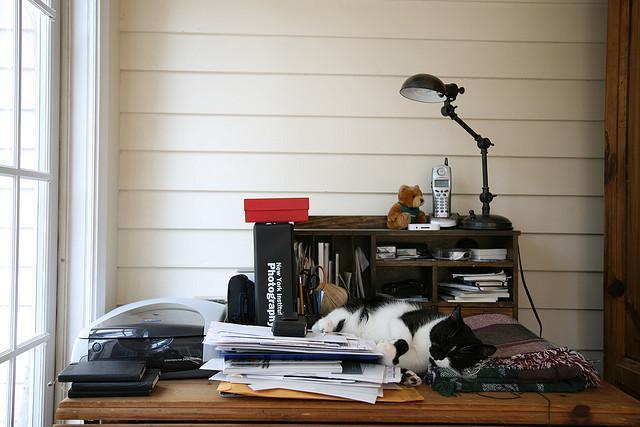How many cats are in the picture?
Give a very brief answer. 1. How many people are wearing a black shirt?
Give a very brief answer. 0. 